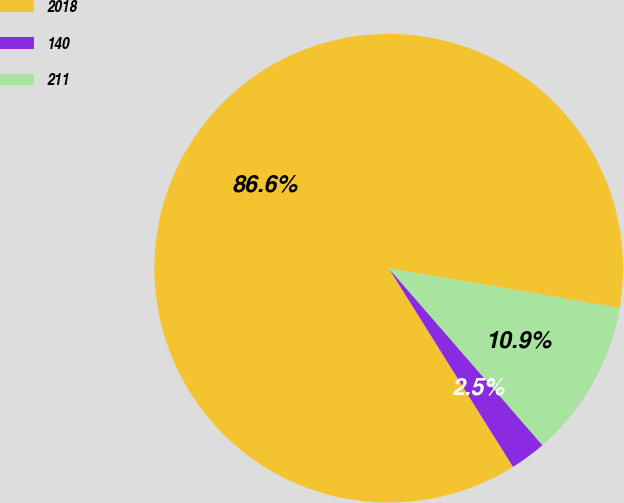Convert chart. <chart><loc_0><loc_0><loc_500><loc_500><pie_chart><fcel>2018<fcel>140<fcel>211<nl><fcel>86.61%<fcel>2.49%<fcel>10.9%<nl></chart> 